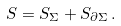Convert formula to latex. <formula><loc_0><loc_0><loc_500><loc_500>S = S _ { \Sigma } + S _ { \partial \Sigma } \, .</formula> 